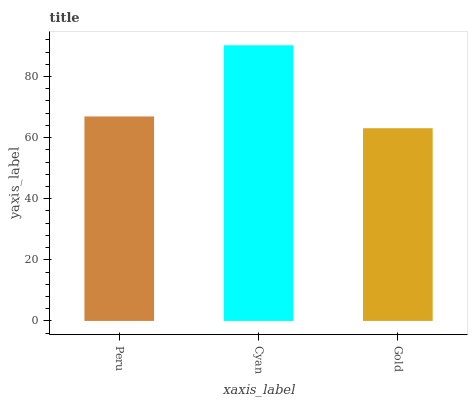Is Gold the minimum?
Answer yes or no. Yes. Is Cyan the maximum?
Answer yes or no. Yes. Is Cyan the minimum?
Answer yes or no. No. Is Gold the maximum?
Answer yes or no. No. Is Cyan greater than Gold?
Answer yes or no. Yes. Is Gold less than Cyan?
Answer yes or no. Yes. Is Gold greater than Cyan?
Answer yes or no. No. Is Cyan less than Gold?
Answer yes or no. No. Is Peru the high median?
Answer yes or no. Yes. Is Peru the low median?
Answer yes or no. Yes. Is Cyan the high median?
Answer yes or no. No. Is Cyan the low median?
Answer yes or no. No. 